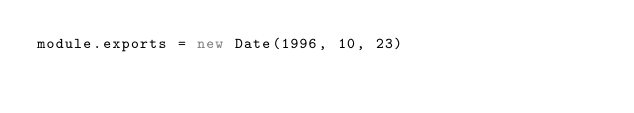<code> <loc_0><loc_0><loc_500><loc_500><_JavaScript_>module.exports = new Date(1996, 10, 23)
</code> 